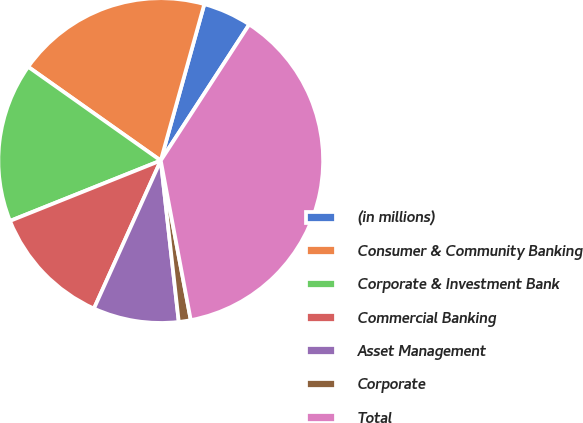Convert chart. <chart><loc_0><loc_0><loc_500><loc_500><pie_chart><fcel>(in millions)<fcel>Consumer & Community Banking<fcel>Corporate & Investment Bank<fcel>Commercial Banking<fcel>Asset Management<fcel>Corporate<fcel>Total<nl><fcel>4.85%<fcel>19.53%<fcel>15.86%<fcel>12.19%<fcel>8.52%<fcel>1.19%<fcel>37.87%<nl></chart> 